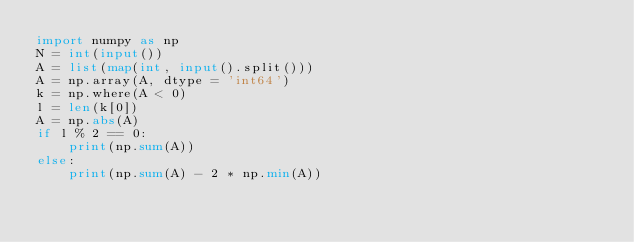Convert code to text. <code><loc_0><loc_0><loc_500><loc_500><_Python_>import numpy as np
N = int(input())
A = list(map(int, input().split()))
A = np.array(A, dtype = 'int64')
k = np.where(A < 0)
l = len(k[0])
A = np.abs(A)
if l % 2 == 0:
    print(np.sum(A))
else:
    print(np.sum(A) - 2 * np.min(A))</code> 